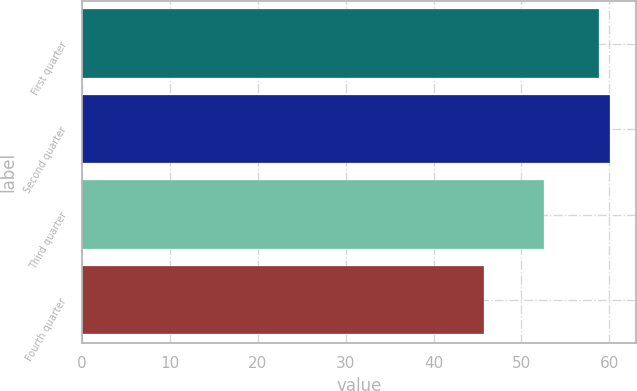Convert chart. <chart><loc_0><loc_0><loc_500><loc_500><bar_chart><fcel>First quarter<fcel>Second quarter<fcel>Third quarter<fcel>Fourth quarter<nl><fcel>58.78<fcel>60.09<fcel>52.55<fcel>45.8<nl></chart> 